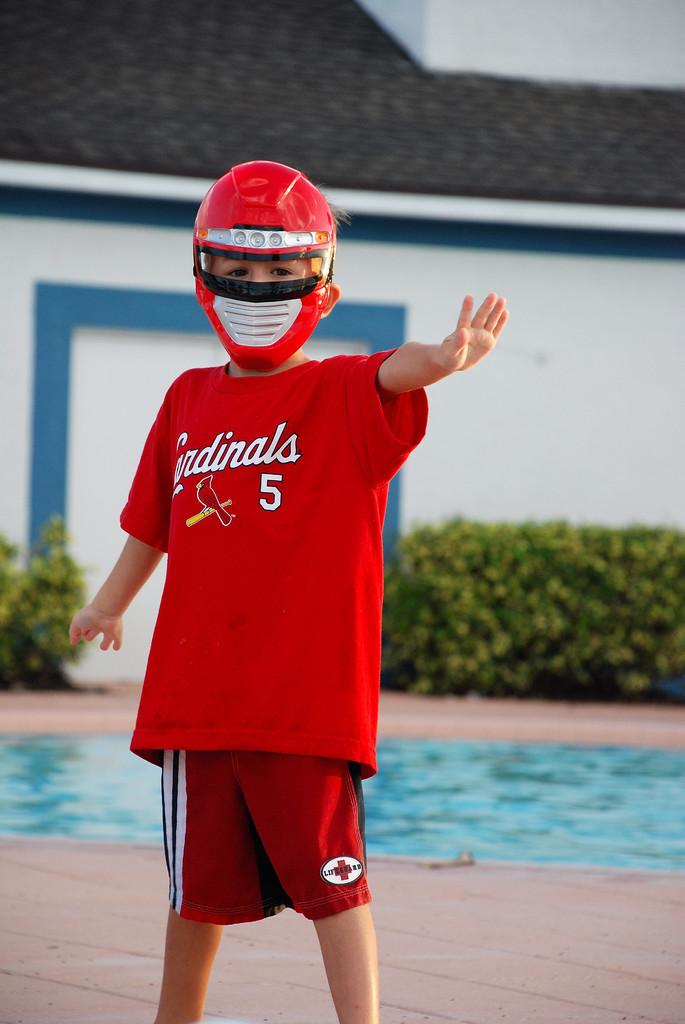Who is the main subject in the image? There is a boy in the center of the image. What is the boy wearing on his head? The boy is wearing a helmet. What can be seen in the background of the image? There is a house and a swimming pool in the background of the image. What is visible at the bottom of the image? The floor is visible at the bottom of the image. What type of condition does the cow have in the image? There is no cow present in the image, so it is not possible to determine any condition. 